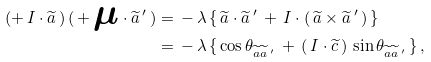<formula> <loc_0><loc_0><loc_500><loc_500>( + \, I \cdot { \widetilde { a } } \, ) \, ( \, + \, { \boldsymbol \mu } \cdot { \widetilde { a } } \, ^ { \prime } \, ) & = \, - \, \lambda \, \{ \, { \widetilde { a } } \cdot { \widetilde { a } \, ^ { \prime } } \, + \, I \cdot ( \, { \widetilde { a } } \times { \widetilde { a } \, ^ { \prime } \, } ) \, \} \\ & = \, - \, \lambda \, \{ \, \cos \theta _ { { \widetilde { a } } { \widetilde { a } \, ^ { \prime } } } \, + \, \left ( \, I \cdot { \widetilde { c } } \, \right ) \, \sin \theta _ { { \widetilde { a } } { \widetilde { a } \, ^ { \prime } } } \, \} \, ,</formula> 